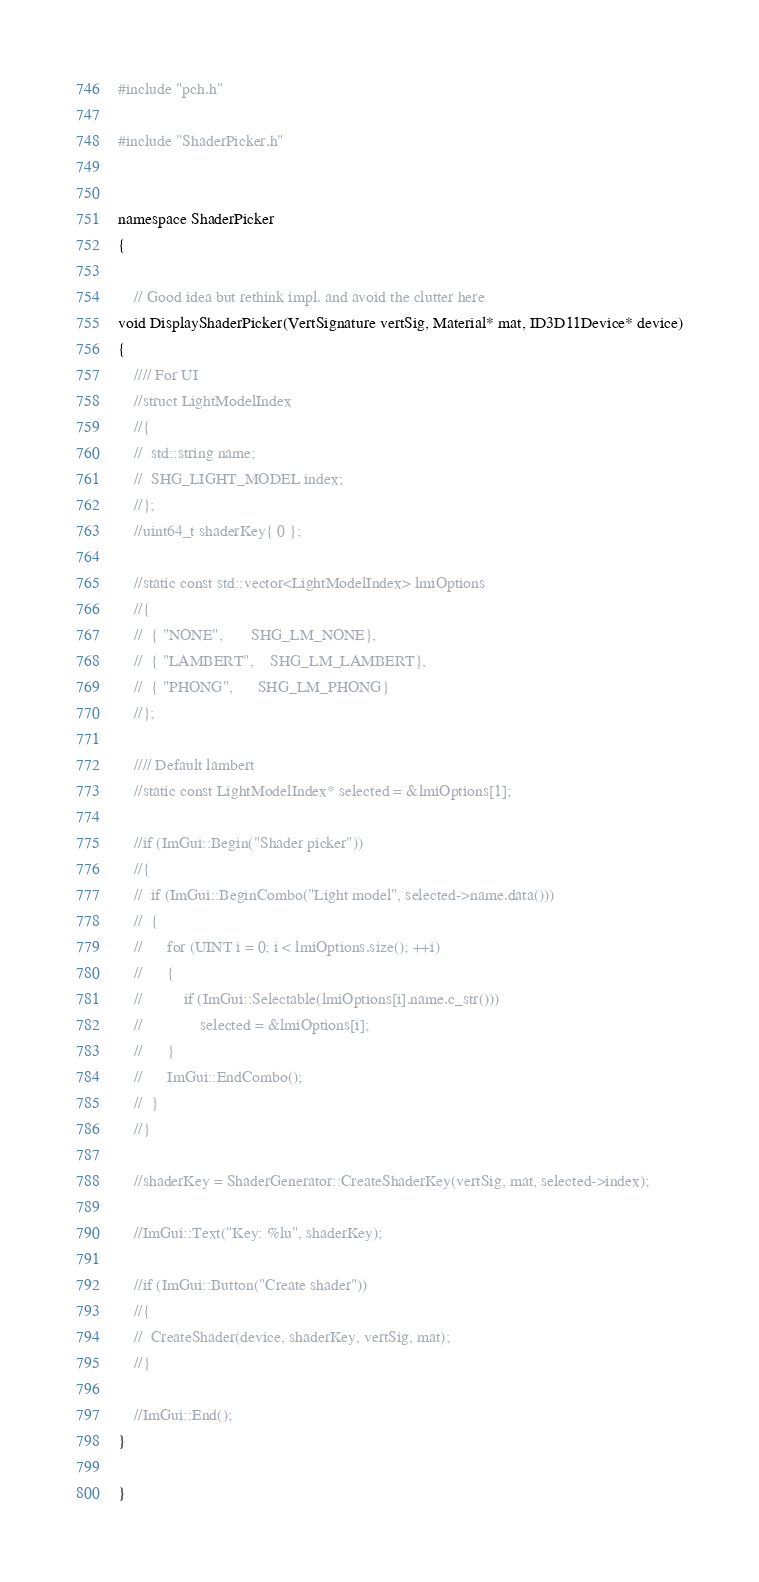Convert code to text. <code><loc_0><loc_0><loc_500><loc_500><_C++_>#include "pch.h"

#include "ShaderPicker.h"


namespace ShaderPicker
{

	// Good idea but rethink impl. and avoid the clutter here
void DisplayShaderPicker(VertSignature vertSig, Material* mat, ID3D11Device* device)
{
	//// For UI
	//struct LightModelIndex
	//{
	//	std::string name;
	//	SHG_LIGHT_MODEL index;
	//};
	//uint64_t shaderKey{ 0 };

	//static const std::vector<LightModelIndex> lmiOptions
	//{
	//	{ "NONE",		SHG_LM_NONE},
	//	{ "LAMBERT",	SHG_LM_LAMBERT},
	//	{ "PHONG",		SHG_LM_PHONG}
	//};

	//// Default lambert
	//static const LightModelIndex* selected = &lmiOptions[1];

	//if (ImGui::Begin("Shader picker"))
	//{
	//	if (ImGui::BeginCombo("Light model", selected->name.data()))
	//	{
	//		for (UINT i = 0; i < lmiOptions.size(); ++i)
	//		{
	//			if (ImGui::Selectable(lmiOptions[i].name.c_str()))
	//				selected = &lmiOptions[i];
	//		}
	//		ImGui::EndCombo();
	//	}
	//}

	//shaderKey = ShaderGenerator::CreateShaderKey(vertSig, mat, selected->index);

	//ImGui::Text("Key: %lu", shaderKey);

	//if (ImGui::Button("Create shader"))
	//{
	//	CreateShader(device, shaderKey, vertSig, mat);
	//}

	//ImGui::End();
}

}</code> 